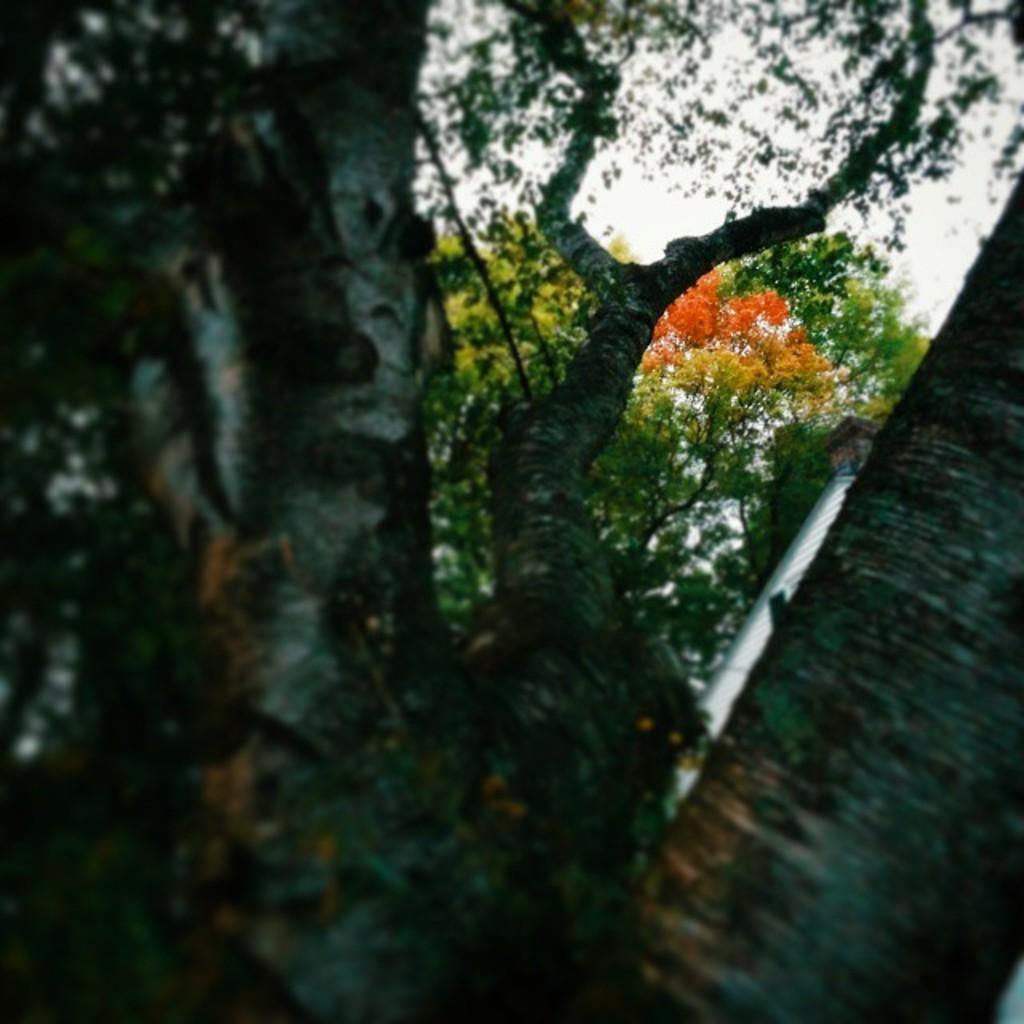Can you describe this image briefly? This picture shows couple of trees and we see a cloudy sky. 